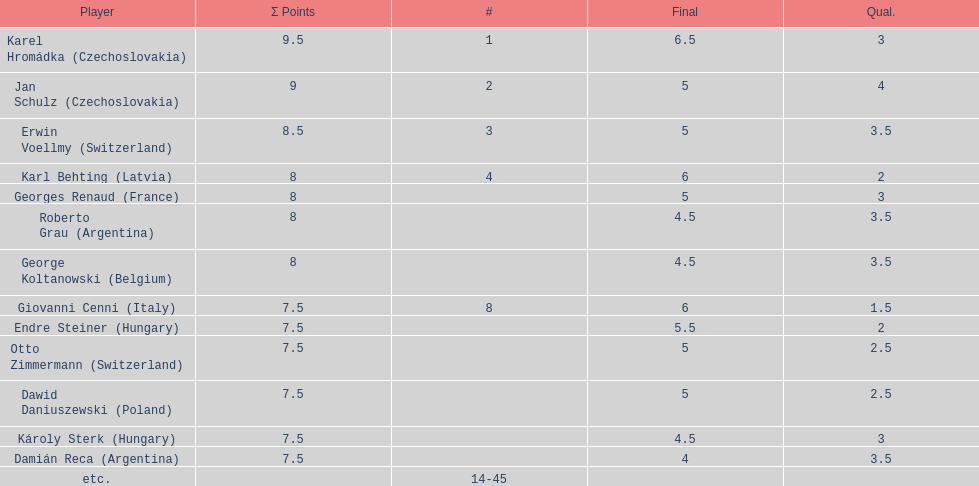How many players tied for 4th place? 4. 